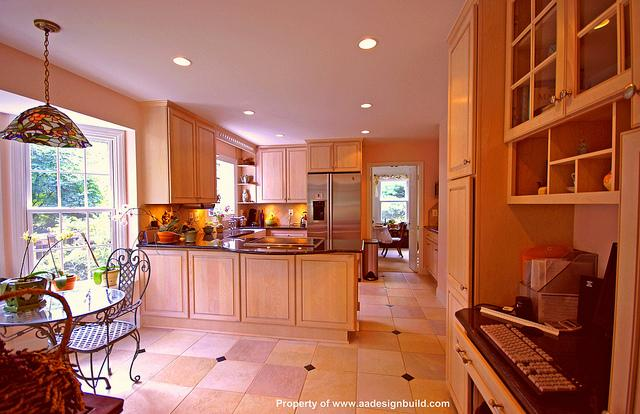What shape is the black tiles on the floor? Please explain your reasoning. diamond. There are a bunch of black diamonds adorning the floor. 